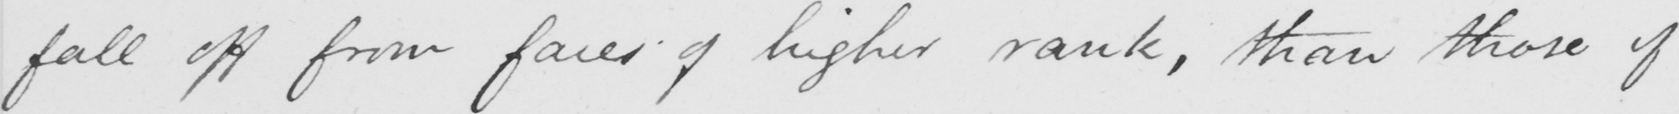What does this handwritten line say? fall off from faces of higher rank , than those of 